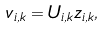<formula> <loc_0><loc_0><loc_500><loc_500>v _ { i , k } = U _ { i , k } z _ { i , k } ,</formula> 